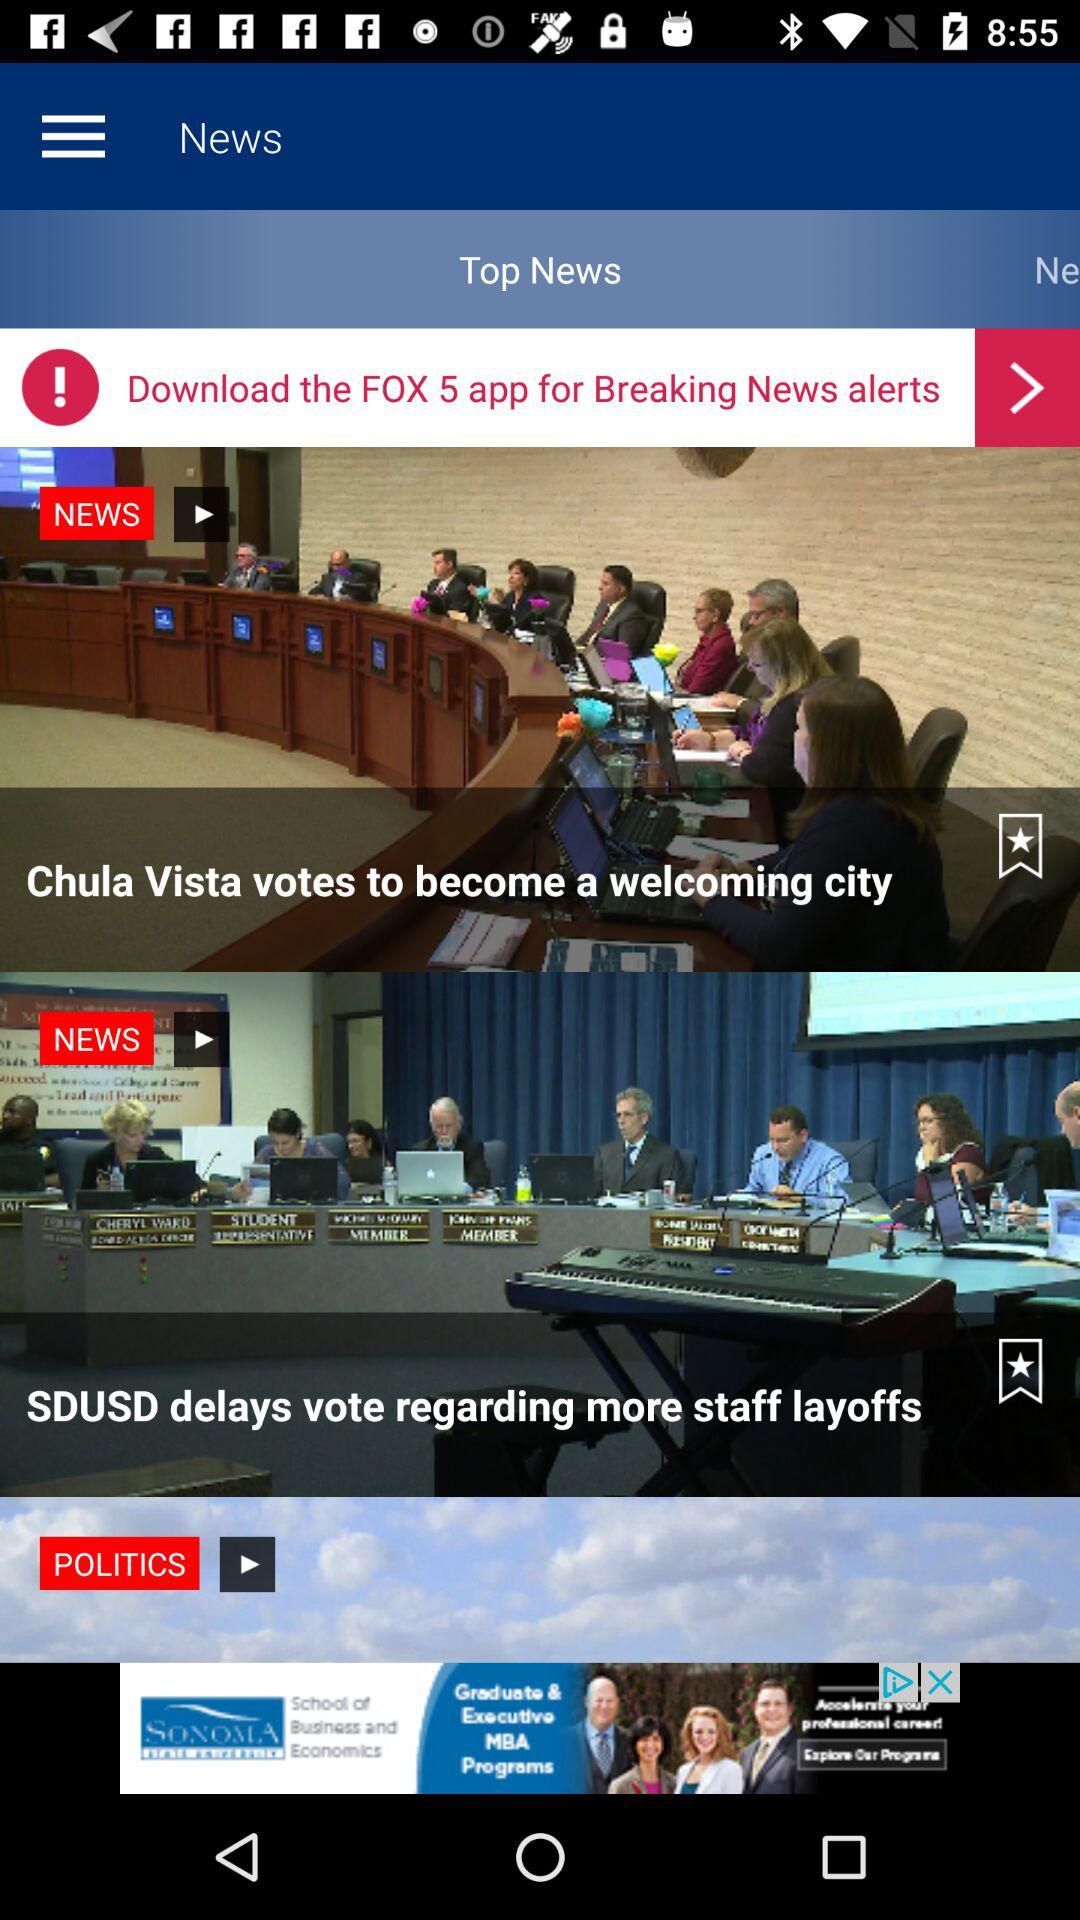How many apps have been downloaded for the Fox 5?
When the provided information is insufficient, respond with <no answer>. <no answer> 